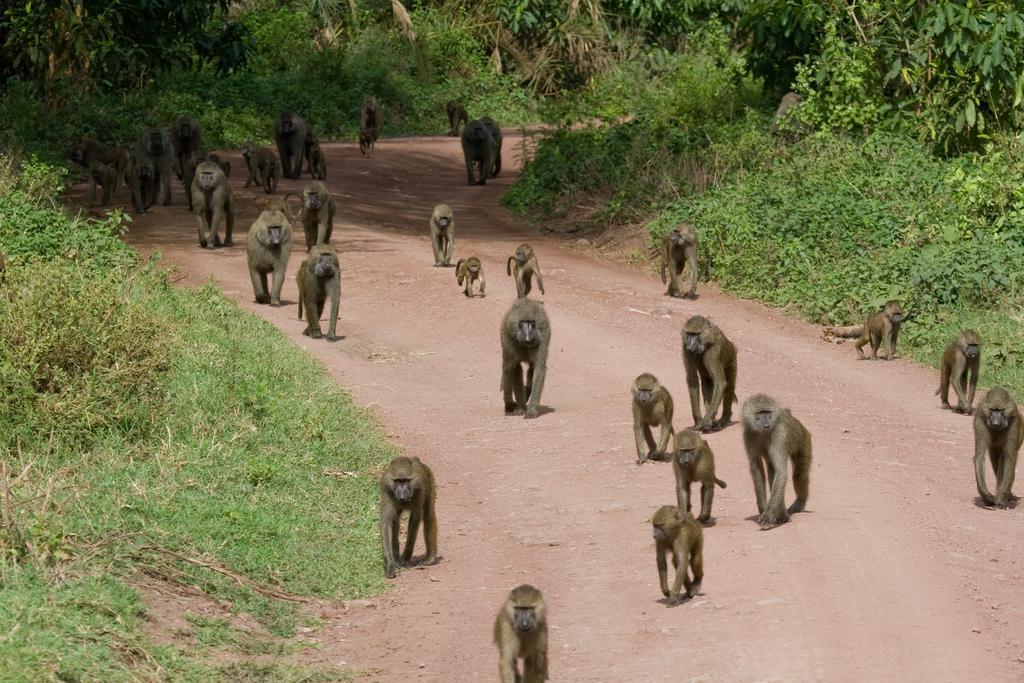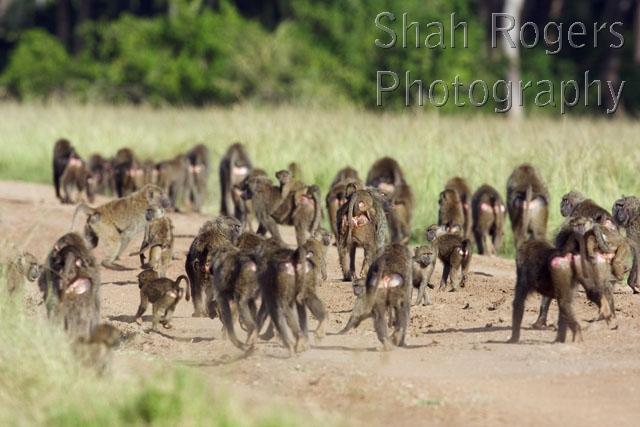The first image is the image on the left, the second image is the image on the right. Assess this claim about the two images: "Right image includes no more than five baboons.". Correct or not? Answer yes or no. No. The first image is the image on the left, the second image is the image on the right. Examine the images to the left and right. Is the description "At least one image shows monkeys that are walking in one direction." accurate? Answer yes or no. Yes. The first image is the image on the left, the second image is the image on the right. Given the left and right images, does the statement "Some of the animals are on or near a dirt path." hold true? Answer yes or no. Yes. 